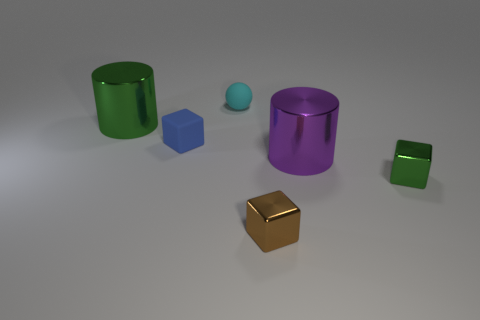What can you say about the textures visible in the image? Each object showcases a smooth, somewhat reflective surface, implying they might be made of materials like plastic or metal. The light in the scene creates subtle highlights and soft shadows on the objects, emphasizing their glossy textures. 